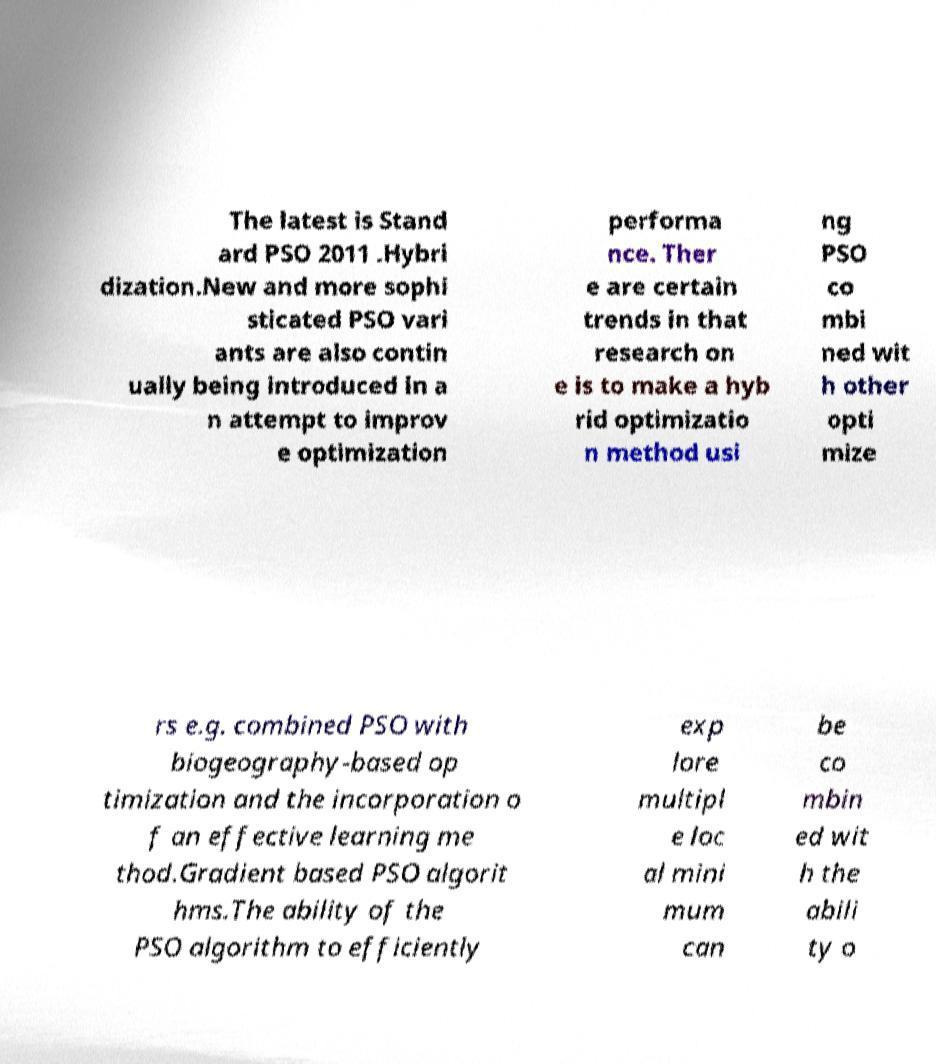What messages or text are displayed in this image? I need them in a readable, typed format. The latest is Stand ard PSO 2011 .Hybri dization.New and more sophi sticated PSO vari ants are also contin ually being introduced in a n attempt to improv e optimization performa nce. Ther e are certain trends in that research on e is to make a hyb rid optimizatio n method usi ng PSO co mbi ned wit h other opti mize rs e.g. combined PSO with biogeography-based op timization and the incorporation o f an effective learning me thod.Gradient based PSO algorit hms.The ability of the PSO algorithm to efficiently exp lore multipl e loc al mini mum can be co mbin ed wit h the abili ty o 